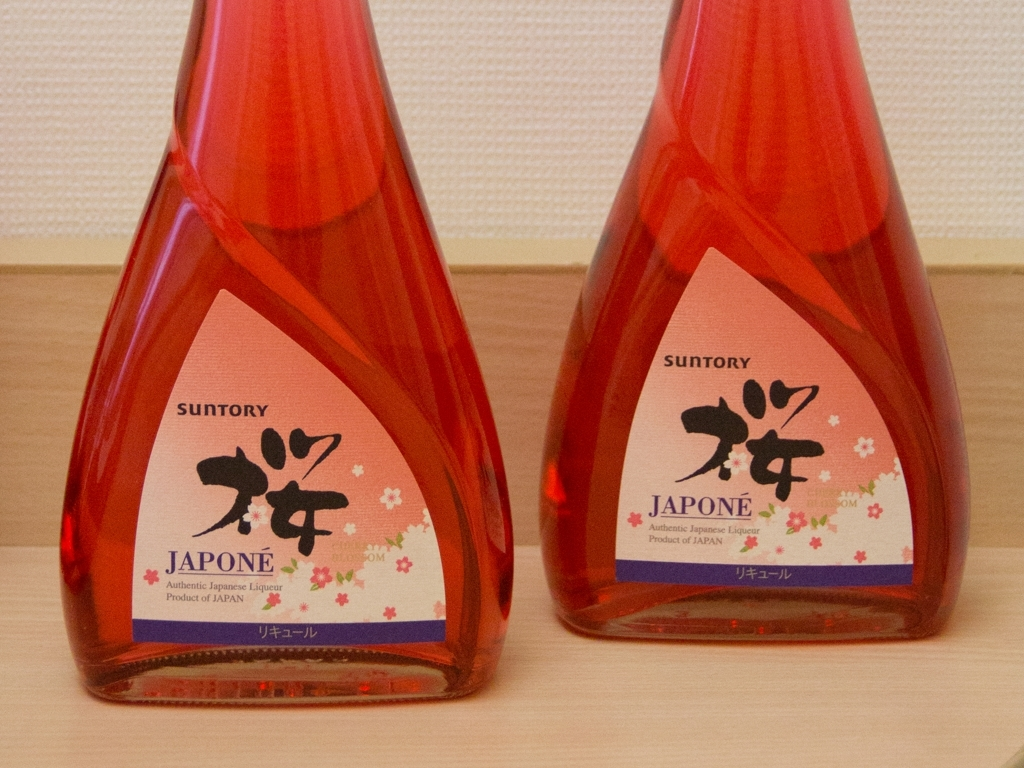Are the colors in the image vibrant? The hues within the image exude a rich vibrancy, with the deep red color of the bottles imbuing a sense of warmth and energy. However, as 'vibrant' can be somewhat subjective, some may find the color to be more subdued than bright or vivid. 